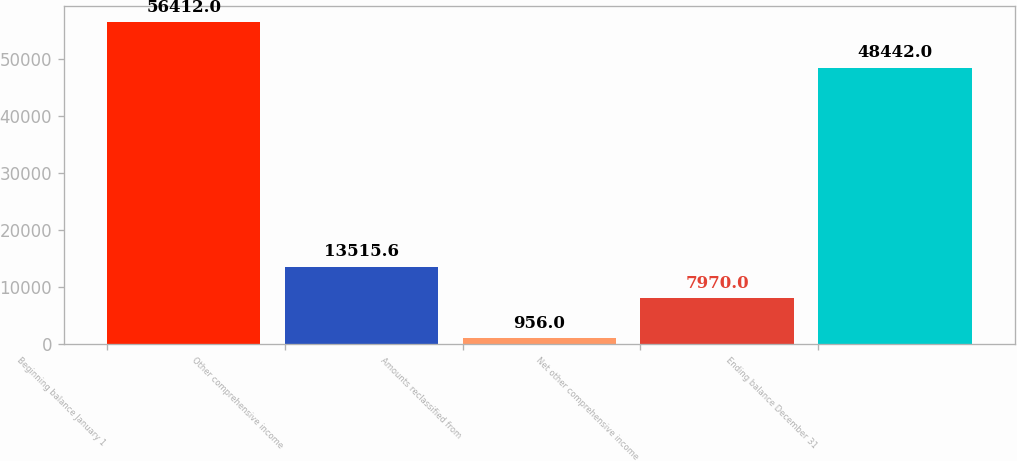<chart> <loc_0><loc_0><loc_500><loc_500><bar_chart><fcel>Beginning balance January 1<fcel>Other comprehensive income<fcel>Amounts reclassified from<fcel>Net other comprehensive income<fcel>Ending balance December 31<nl><fcel>56412<fcel>13515.6<fcel>956<fcel>7970<fcel>48442<nl></chart> 